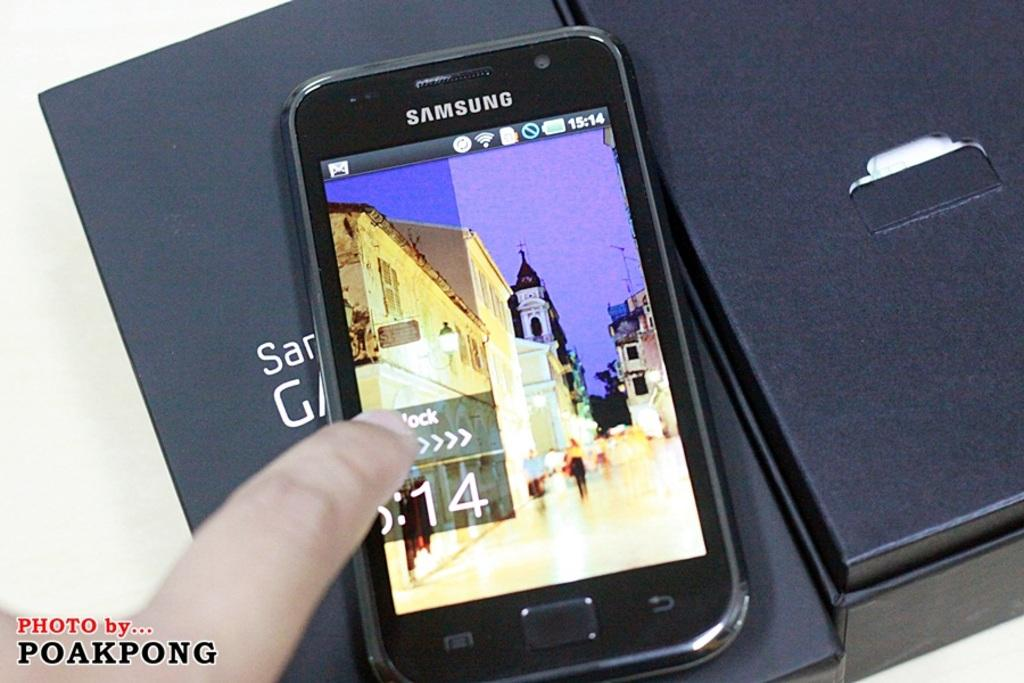<image>
Offer a succinct explanation of the picture presented. Poakpong took this photo of a Samsung phone. 